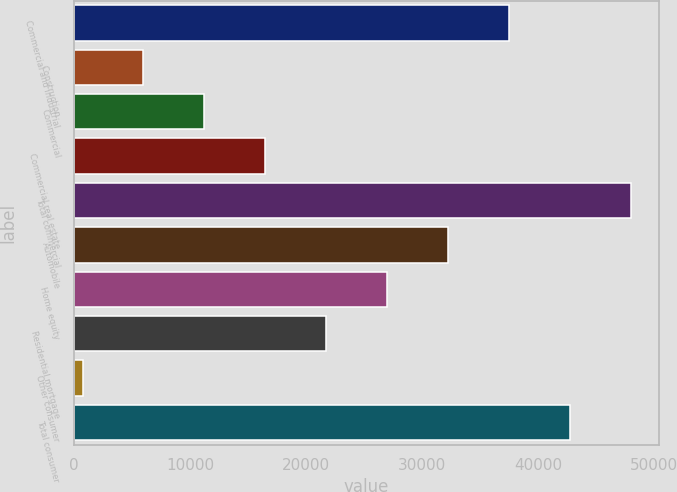Convert chart to OTSL. <chart><loc_0><loc_0><loc_500><loc_500><bar_chart><fcel>Commercial and industrial<fcel>Construction<fcel>Commercial<fcel>Commercial real estate<fcel>Total commercial<fcel>Automobile<fcel>Home equity<fcel>Residential mortgage<fcel>Other consumer<fcel>Total consumer<nl><fcel>37491.9<fcel>5981.7<fcel>11233.4<fcel>16485.1<fcel>47995.3<fcel>32240.2<fcel>26988.5<fcel>21736.8<fcel>730<fcel>42743.6<nl></chart> 